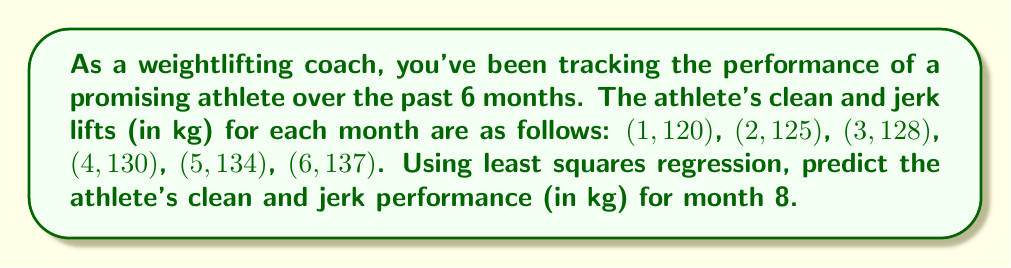Could you help me with this problem? Let's solve this using least squares regression:

1) First, we need to calculate the following sums:
   $n = 6$, $\sum x = 21$, $\sum y = 774$, $\sum x^2 = 91$, $\sum xy = 2805$

2) Now we can use these formulas to find the slope (m) and y-intercept (b):

   $$m = \frac{n\sum xy - \sum x \sum y}{n\sum x^2 - (\sum x)^2}$$

   $$b = \frac{\sum y - m\sum x}{n}$$

3) Let's calculate m:

   $$m = \frac{6(2805) - 21(774)}{6(91) - 21^2} = \frac{16830 - 16254}{546 - 441} = \frac{576}{105} = 5.4857$$

4) Now let's calculate b:

   $$b = \frac{774 - 5.4857(21)}{6} = \frac{774 - 115.1997}{6} = 109.8$$

5) Our regression line equation is:

   $$y = 5.4857x + 109.8$$

6) To predict the performance for month 8, we substitute x = 8:

   $$y = 5.4857(8) + 109.8 = 153.6856$$
Answer: 153.69 kg 